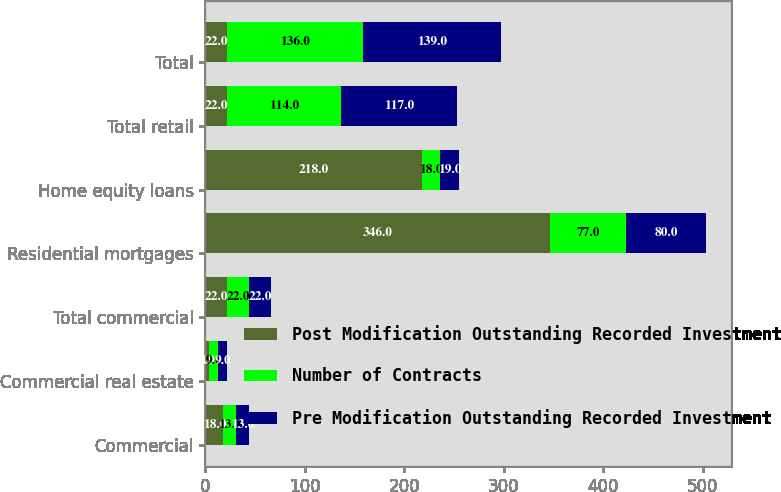Convert chart. <chart><loc_0><loc_0><loc_500><loc_500><stacked_bar_chart><ecel><fcel>Commercial<fcel>Commercial real estate<fcel>Total commercial<fcel>Residential mortgages<fcel>Home equity loans<fcel>Total retail<fcel>Total<nl><fcel>Post Modification Outstanding Recorded Investment<fcel>18<fcel>4<fcel>22<fcel>346<fcel>218<fcel>22<fcel>22<nl><fcel>Number of Contracts<fcel>13<fcel>9<fcel>22<fcel>77<fcel>18<fcel>114<fcel>136<nl><fcel>Pre Modification Outstanding Recorded Investment<fcel>13<fcel>9<fcel>22<fcel>80<fcel>19<fcel>117<fcel>139<nl></chart> 